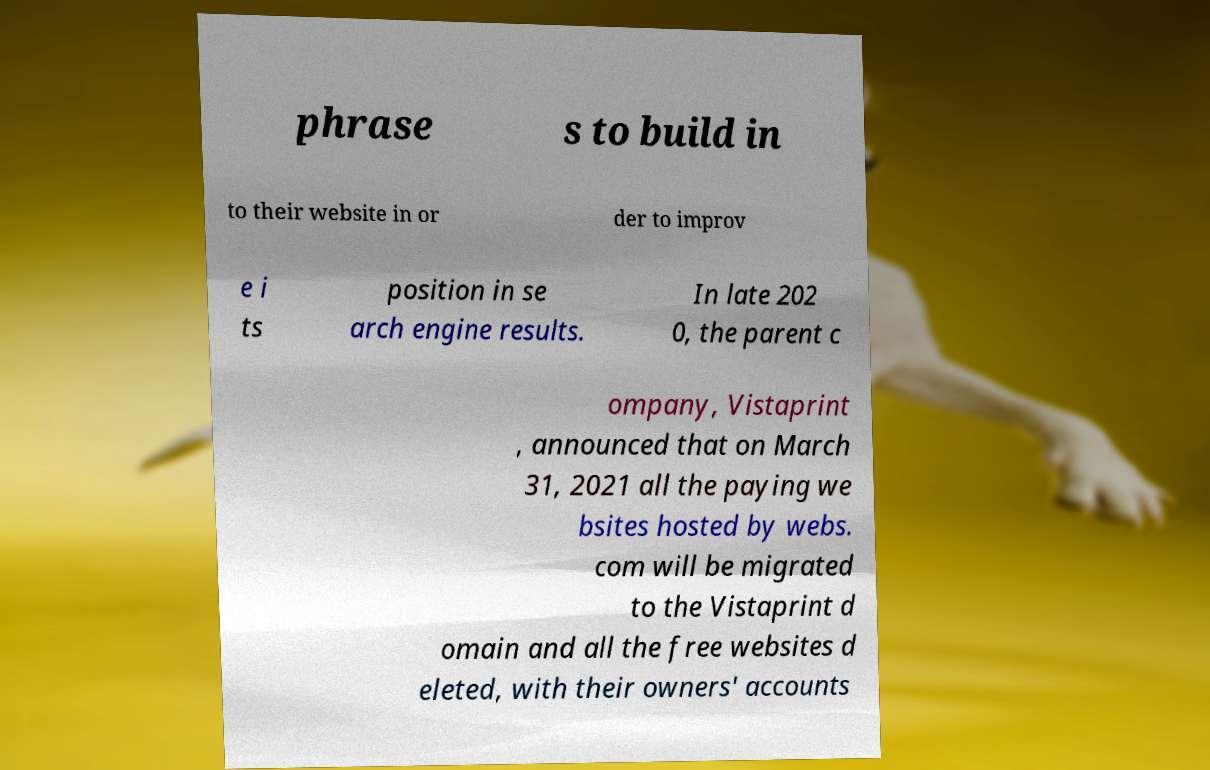Can you read and provide the text displayed in the image?This photo seems to have some interesting text. Can you extract and type it out for me? phrase s to build in to their website in or der to improv e i ts position in se arch engine results. In late 202 0, the parent c ompany, Vistaprint , announced that on March 31, 2021 all the paying we bsites hosted by webs. com will be migrated to the Vistaprint d omain and all the free websites d eleted, with their owners' accounts 